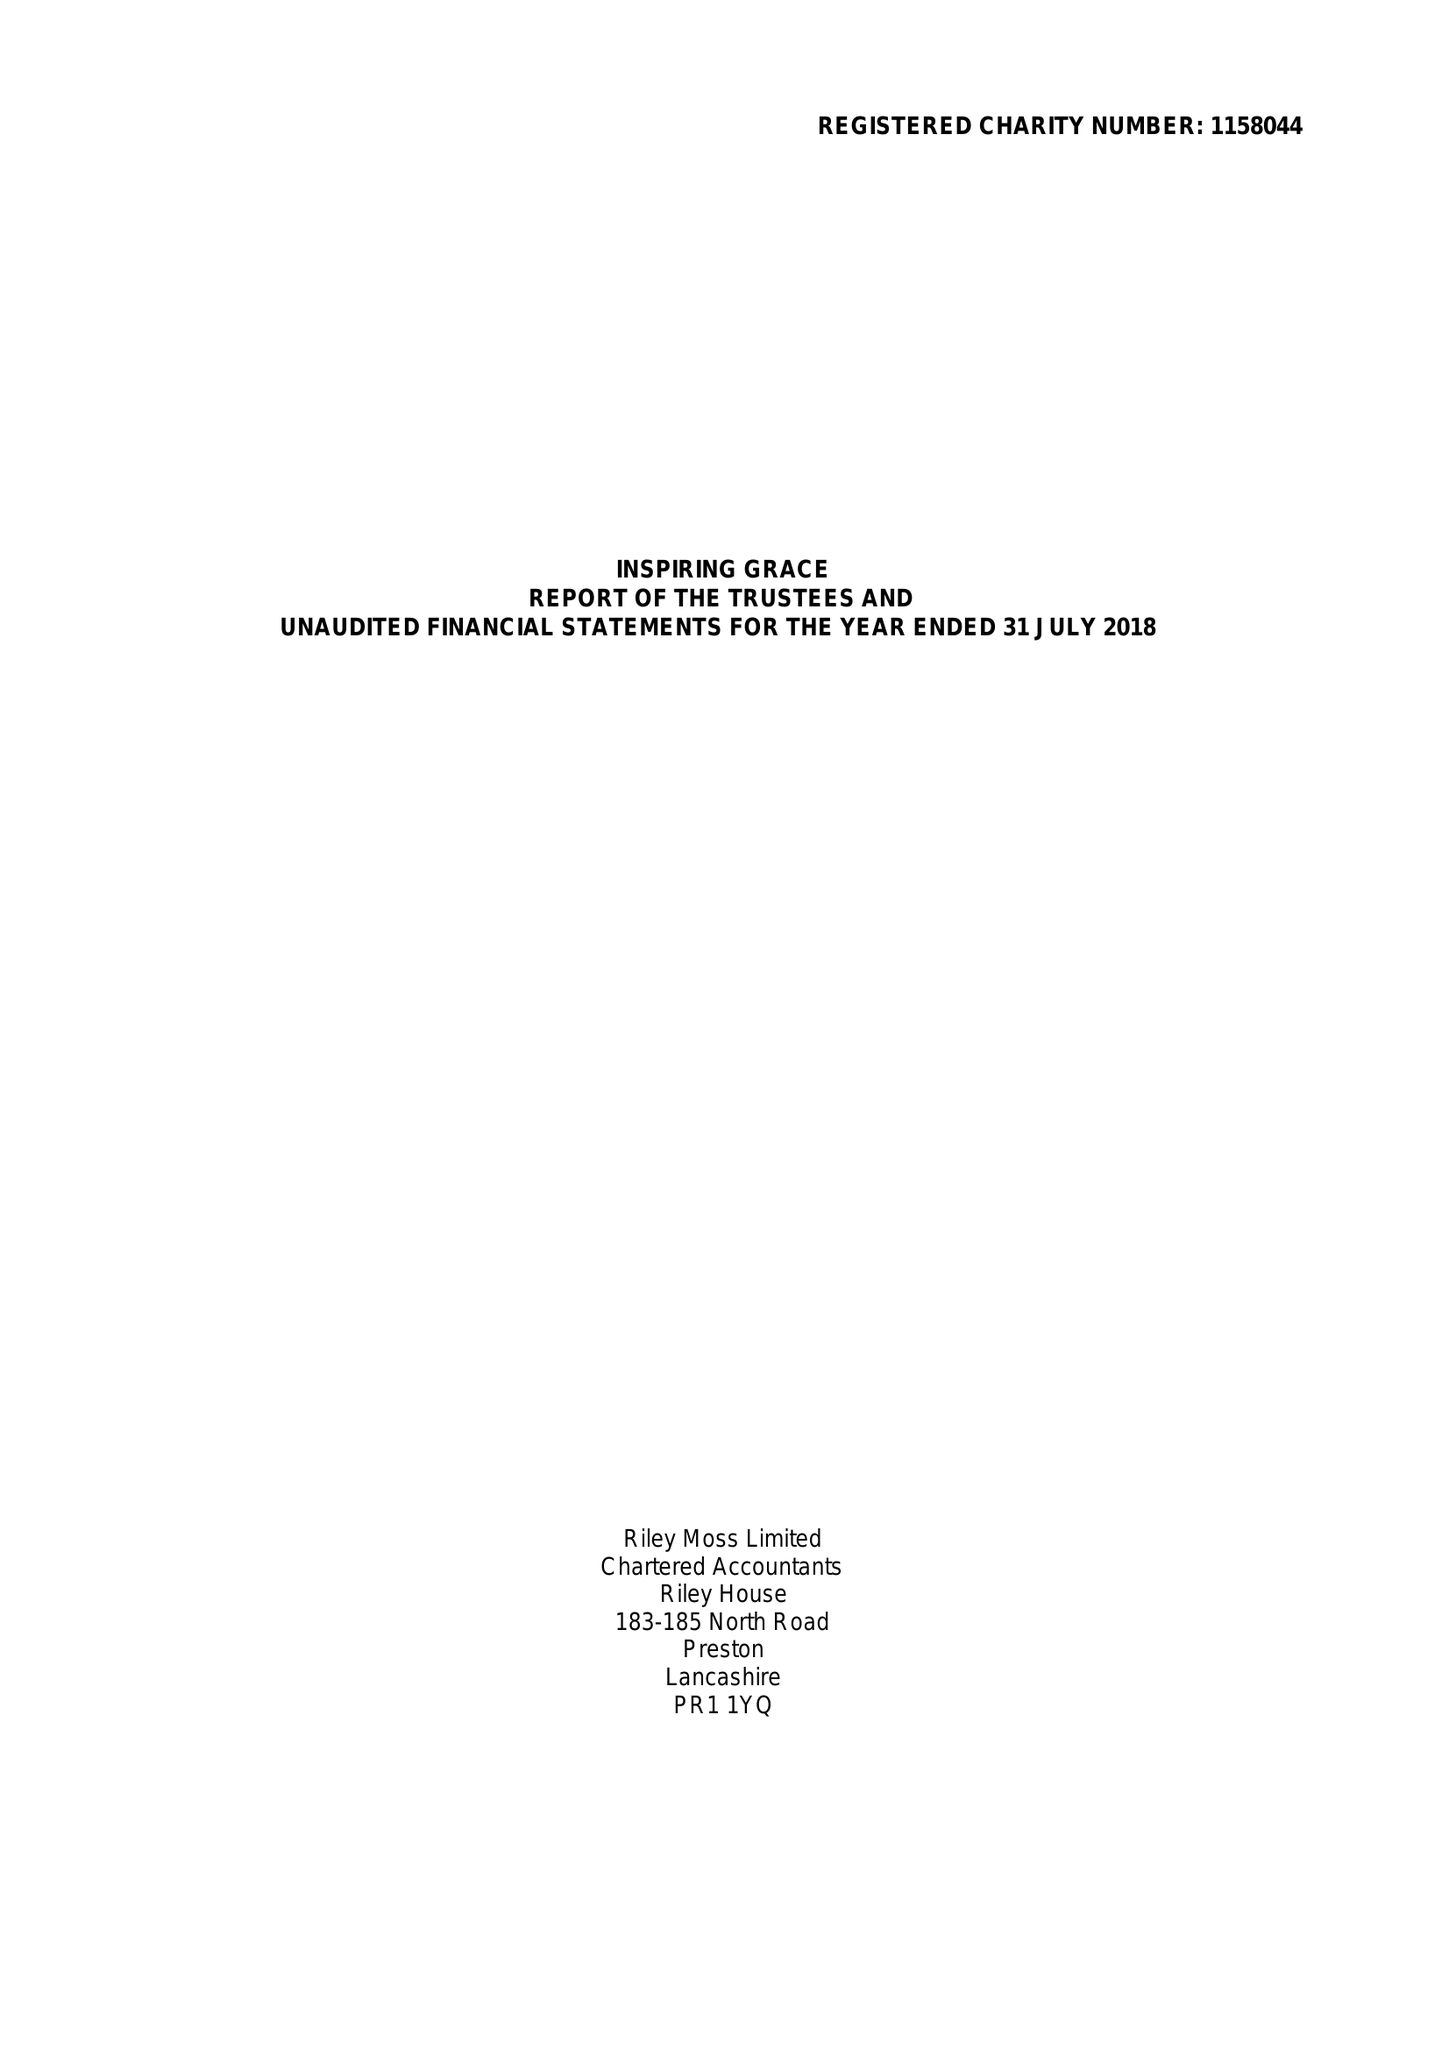What is the value for the address__post_town?
Answer the question using a single word or phrase. NELSON 